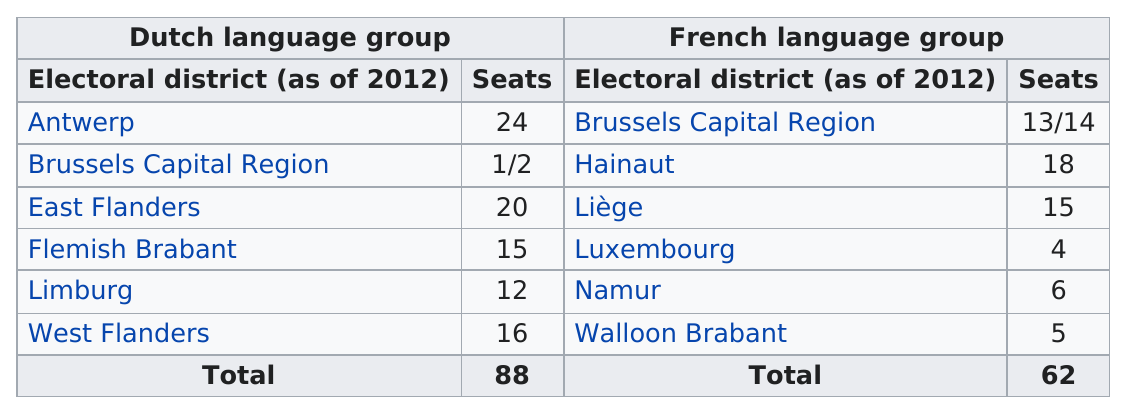List a handful of essential elements in this visual. Antwerp provides approximately 16% of the total number of seats across both language groups. Antwerp, the Dutch-speaking electoral district in Belgium, has the most seats in parliament. In the regions of Antwerp, East Flanders, Flemish Brabant, West Flanders, Hainaut, and Liège, there are electoral districts that hold 15 or more seats. The Brussels Capital Region is the electoral district in which there are representatives from both the Dutch language and French language groups. Antwerp electoral district has the most seats allotted to it in the Dutch language group. 